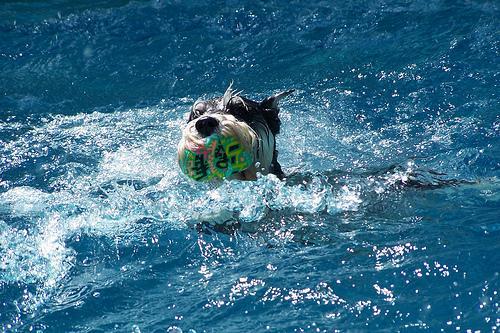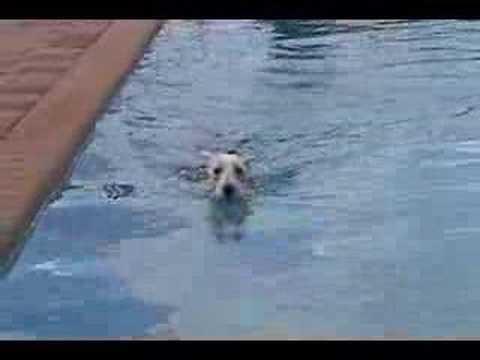The first image is the image on the left, the second image is the image on the right. For the images displayed, is the sentence "An image shows a dog in a swim ring in a pool." factually correct? Answer yes or no. No. The first image is the image on the left, the second image is the image on the right. Assess this claim about the two images: "At least one of the dogs is on a floatation device.". Correct or not? Answer yes or no. No. 